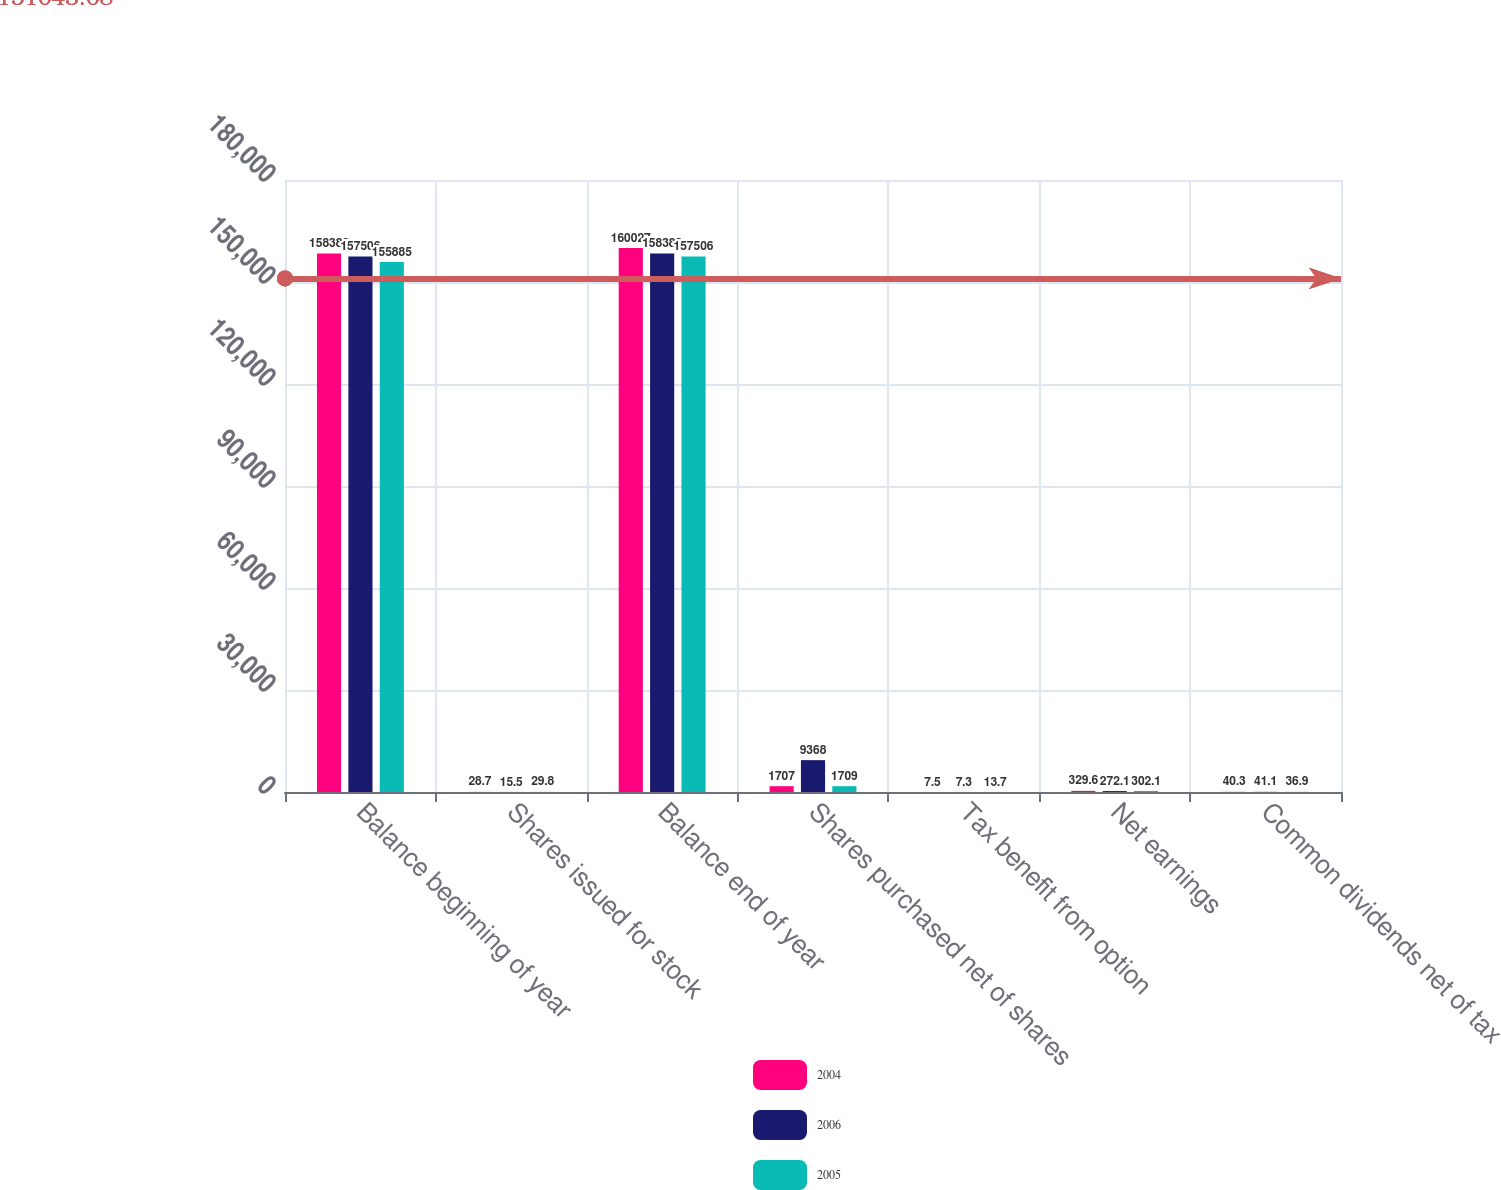Convert chart. <chart><loc_0><loc_0><loc_500><loc_500><stacked_bar_chart><ecel><fcel>Balance beginning of year<fcel>Shares issued for stock<fcel>Balance end of year<fcel>Shares purchased net of shares<fcel>Tax benefit from option<fcel>Net earnings<fcel>Common dividends net of tax<nl><fcel>2004<fcel>158383<fcel>28.7<fcel>160027<fcel>1707<fcel>7.5<fcel>329.6<fcel>40.3<nl><fcel>2006<fcel>157506<fcel>15.5<fcel>158383<fcel>9368<fcel>7.3<fcel>272.1<fcel>41.1<nl><fcel>2005<fcel>155885<fcel>29.8<fcel>157506<fcel>1709<fcel>13.7<fcel>302.1<fcel>36.9<nl></chart> 